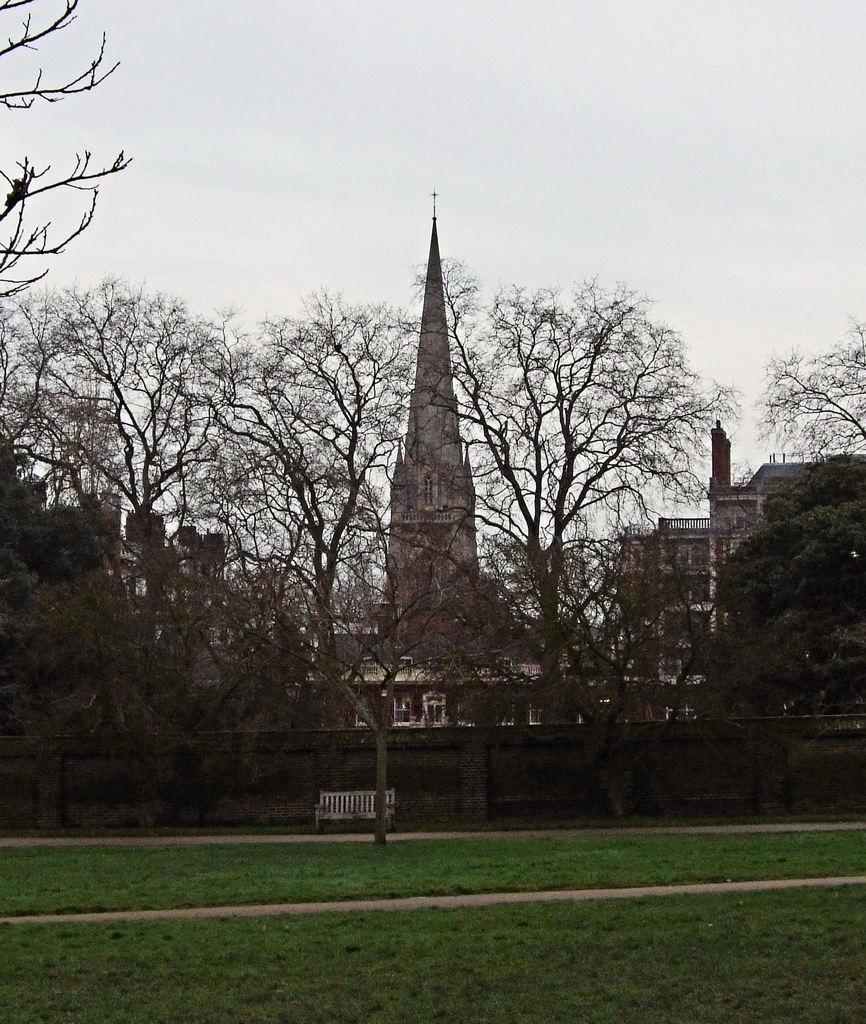What type of vegetation is in the front of the image? There is a green lawn in the front of the image. What is the condition of the trees visible in the image? The trees visible in the image are dry. What type of building can be seen in the image? There is a brown tower building in the image. What is visible at the top of the image? The sky is visible at the top of the image. Where are the chickens located in the image? There are no chickens present in the image. What is the purpose of the icicles in the image? There are no icicles present in the image. 